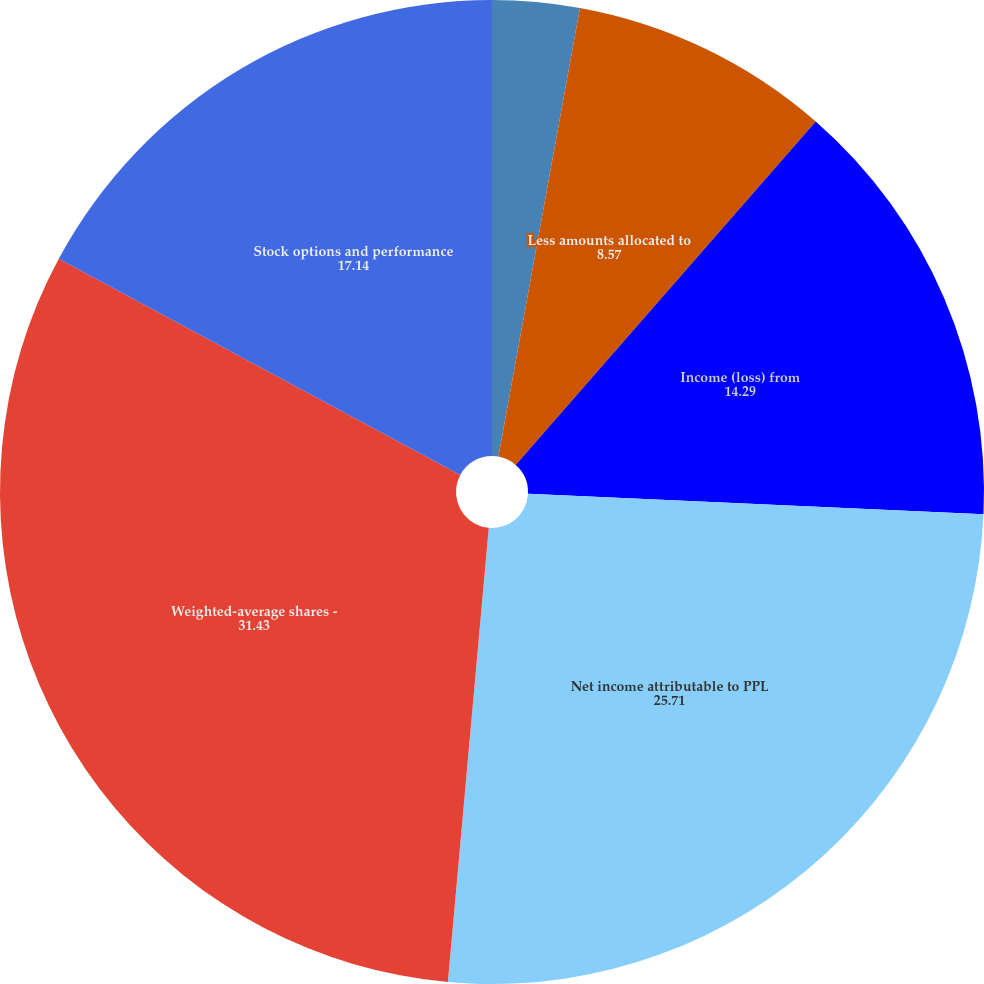Convert chart. <chart><loc_0><loc_0><loc_500><loc_500><pie_chart><fcel>Income from continuing<fcel>Less amounts allocated to<fcel>Income (loss) from<fcel>Net income attributable to PPL<fcel>Weighted-average shares -<fcel>Stock options and performance<nl><fcel>2.86%<fcel>8.57%<fcel>14.29%<fcel>25.71%<fcel>31.43%<fcel>17.14%<nl></chart> 